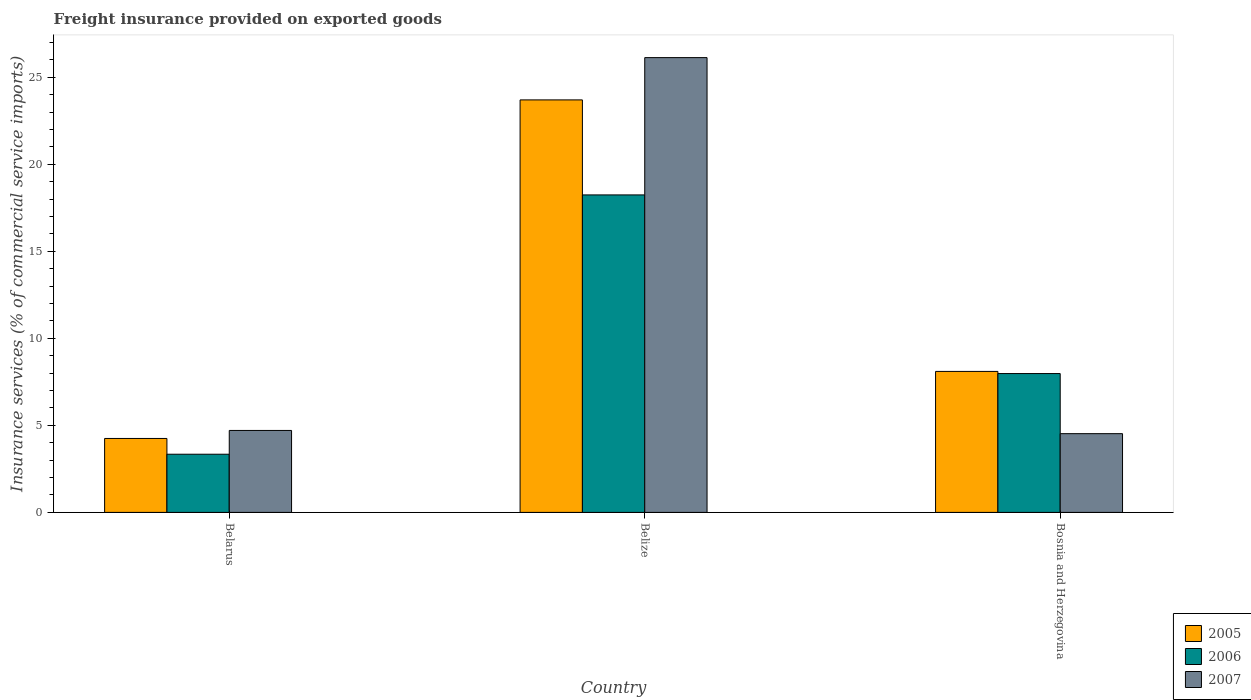How many groups of bars are there?
Offer a terse response. 3. Are the number of bars per tick equal to the number of legend labels?
Your response must be concise. Yes. How many bars are there on the 2nd tick from the right?
Your answer should be very brief. 3. What is the label of the 3rd group of bars from the left?
Offer a terse response. Bosnia and Herzegovina. What is the freight insurance provided on exported goods in 2007 in Belize?
Provide a succinct answer. 26.13. Across all countries, what is the maximum freight insurance provided on exported goods in 2007?
Ensure brevity in your answer.  26.13. Across all countries, what is the minimum freight insurance provided on exported goods in 2006?
Ensure brevity in your answer.  3.34. In which country was the freight insurance provided on exported goods in 2005 maximum?
Offer a terse response. Belize. In which country was the freight insurance provided on exported goods in 2007 minimum?
Offer a very short reply. Bosnia and Herzegovina. What is the total freight insurance provided on exported goods in 2006 in the graph?
Keep it short and to the point. 29.56. What is the difference between the freight insurance provided on exported goods in 2006 in Belarus and that in Bosnia and Herzegovina?
Your answer should be very brief. -4.63. What is the difference between the freight insurance provided on exported goods in 2007 in Belize and the freight insurance provided on exported goods in 2005 in Belarus?
Provide a succinct answer. 21.88. What is the average freight insurance provided on exported goods in 2006 per country?
Make the answer very short. 9.85. What is the difference between the freight insurance provided on exported goods of/in 2007 and freight insurance provided on exported goods of/in 2005 in Belize?
Your answer should be very brief. 2.43. In how many countries, is the freight insurance provided on exported goods in 2005 greater than 25 %?
Your response must be concise. 0. What is the ratio of the freight insurance provided on exported goods in 2007 in Belarus to that in Bosnia and Herzegovina?
Offer a terse response. 1.04. Is the freight insurance provided on exported goods in 2007 in Belarus less than that in Bosnia and Herzegovina?
Give a very brief answer. No. Is the difference between the freight insurance provided on exported goods in 2007 in Belarus and Belize greater than the difference between the freight insurance provided on exported goods in 2005 in Belarus and Belize?
Ensure brevity in your answer.  No. What is the difference between the highest and the second highest freight insurance provided on exported goods in 2007?
Ensure brevity in your answer.  21.42. What is the difference between the highest and the lowest freight insurance provided on exported goods in 2007?
Give a very brief answer. 21.6. In how many countries, is the freight insurance provided on exported goods in 2005 greater than the average freight insurance provided on exported goods in 2005 taken over all countries?
Provide a succinct answer. 1. Is the sum of the freight insurance provided on exported goods in 2005 in Belarus and Bosnia and Herzegovina greater than the maximum freight insurance provided on exported goods in 2006 across all countries?
Make the answer very short. No. Are all the bars in the graph horizontal?
Offer a terse response. No. How many countries are there in the graph?
Provide a short and direct response. 3. Does the graph contain any zero values?
Offer a terse response. No. Does the graph contain grids?
Give a very brief answer. No. Where does the legend appear in the graph?
Your answer should be compact. Bottom right. How many legend labels are there?
Provide a short and direct response. 3. How are the legend labels stacked?
Ensure brevity in your answer.  Vertical. What is the title of the graph?
Your response must be concise. Freight insurance provided on exported goods. What is the label or title of the X-axis?
Make the answer very short. Country. What is the label or title of the Y-axis?
Offer a very short reply. Insurance services (% of commercial service imports). What is the Insurance services (% of commercial service imports) of 2005 in Belarus?
Keep it short and to the point. 4.25. What is the Insurance services (% of commercial service imports) in 2006 in Belarus?
Your response must be concise. 3.34. What is the Insurance services (% of commercial service imports) in 2007 in Belarus?
Ensure brevity in your answer.  4.71. What is the Insurance services (% of commercial service imports) in 2005 in Belize?
Offer a terse response. 23.7. What is the Insurance services (% of commercial service imports) in 2006 in Belize?
Make the answer very short. 18.24. What is the Insurance services (% of commercial service imports) of 2007 in Belize?
Provide a succinct answer. 26.13. What is the Insurance services (% of commercial service imports) in 2005 in Bosnia and Herzegovina?
Make the answer very short. 8.1. What is the Insurance services (% of commercial service imports) of 2006 in Bosnia and Herzegovina?
Your answer should be compact. 7.98. What is the Insurance services (% of commercial service imports) of 2007 in Bosnia and Herzegovina?
Your response must be concise. 4.52. Across all countries, what is the maximum Insurance services (% of commercial service imports) of 2005?
Your response must be concise. 23.7. Across all countries, what is the maximum Insurance services (% of commercial service imports) of 2006?
Make the answer very short. 18.24. Across all countries, what is the maximum Insurance services (% of commercial service imports) in 2007?
Provide a short and direct response. 26.13. Across all countries, what is the minimum Insurance services (% of commercial service imports) of 2005?
Keep it short and to the point. 4.25. Across all countries, what is the minimum Insurance services (% of commercial service imports) of 2006?
Your response must be concise. 3.34. Across all countries, what is the minimum Insurance services (% of commercial service imports) of 2007?
Make the answer very short. 4.52. What is the total Insurance services (% of commercial service imports) in 2005 in the graph?
Your answer should be very brief. 36.04. What is the total Insurance services (% of commercial service imports) in 2006 in the graph?
Offer a terse response. 29.56. What is the total Insurance services (% of commercial service imports) of 2007 in the graph?
Make the answer very short. 35.36. What is the difference between the Insurance services (% of commercial service imports) of 2005 in Belarus and that in Belize?
Offer a very short reply. -19.45. What is the difference between the Insurance services (% of commercial service imports) of 2006 in Belarus and that in Belize?
Offer a terse response. -14.9. What is the difference between the Insurance services (% of commercial service imports) in 2007 in Belarus and that in Belize?
Ensure brevity in your answer.  -21.42. What is the difference between the Insurance services (% of commercial service imports) of 2005 in Belarus and that in Bosnia and Herzegovina?
Keep it short and to the point. -3.85. What is the difference between the Insurance services (% of commercial service imports) of 2006 in Belarus and that in Bosnia and Herzegovina?
Offer a terse response. -4.63. What is the difference between the Insurance services (% of commercial service imports) of 2007 in Belarus and that in Bosnia and Herzegovina?
Your answer should be compact. 0.18. What is the difference between the Insurance services (% of commercial service imports) of 2005 in Belize and that in Bosnia and Herzegovina?
Offer a terse response. 15.6. What is the difference between the Insurance services (% of commercial service imports) of 2006 in Belize and that in Bosnia and Herzegovina?
Your response must be concise. 10.26. What is the difference between the Insurance services (% of commercial service imports) of 2007 in Belize and that in Bosnia and Herzegovina?
Provide a succinct answer. 21.6. What is the difference between the Insurance services (% of commercial service imports) in 2005 in Belarus and the Insurance services (% of commercial service imports) in 2006 in Belize?
Keep it short and to the point. -13.99. What is the difference between the Insurance services (% of commercial service imports) in 2005 in Belarus and the Insurance services (% of commercial service imports) in 2007 in Belize?
Your answer should be very brief. -21.88. What is the difference between the Insurance services (% of commercial service imports) of 2006 in Belarus and the Insurance services (% of commercial service imports) of 2007 in Belize?
Your answer should be very brief. -22.78. What is the difference between the Insurance services (% of commercial service imports) of 2005 in Belarus and the Insurance services (% of commercial service imports) of 2006 in Bosnia and Herzegovina?
Your response must be concise. -3.73. What is the difference between the Insurance services (% of commercial service imports) of 2005 in Belarus and the Insurance services (% of commercial service imports) of 2007 in Bosnia and Herzegovina?
Offer a terse response. -0.28. What is the difference between the Insurance services (% of commercial service imports) in 2006 in Belarus and the Insurance services (% of commercial service imports) in 2007 in Bosnia and Herzegovina?
Your answer should be compact. -1.18. What is the difference between the Insurance services (% of commercial service imports) of 2005 in Belize and the Insurance services (% of commercial service imports) of 2006 in Bosnia and Herzegovina?
Make the answer very short. 15.72. What is the difference between the Insurance services (% of commercial service imports) of 2005 in Belize and the Insurance services (% of commercial service imports) of 2007 in Bosnia and Herzegovina?
Provide a short and direct response. 19.17. What is the difference between the Insurance services (% of commercial service imports) of 2006 in Belize and the Insurance services (% of commercial service imports) of 2007 in Bosnia and Herzegovina?
Keep it short and to the point. 13.71. What is the average Insurance services (% of commercial service imports) in 2005 per country?
Provide a short and direct response. 12.01. What is the average Insurance services (% of commercial service imports) of 2006 per country?
Ensure brevity in your answer.  9.85. What is the average Insurance services (% of commercial service imports) of 2007 per country?
Your answer should be very brief. 11.79. What is the difference between the Insurance services (% of commercial service imports) of 2005 and Insurance services (% of commercial service imports) of 2006 in Belarus?
Offer a terse response. 0.91. What is the difference between the Insurance services (% of commercial service imports) of 2005 and Insurance services (% of commercial service imports) of 2007 in Belarus?
Ensure brevity in your answer.  -0.46. What is the difference between the Insurance services (% of commercial service imports) in 2006 and Insurance services (% of commercial service imports) in 2007 in Belarus?
Provide a short and direct response. -1.37. What is the difference between the Insurance services (% of commercial service imports) of 2005 and Insurance services (% of commercial service imports) of 2006 in Belize?
Your answer should be compact. 5.46. What is the difference between the Insurance services (% of commercial service imports) of 2005 and Insurance services (% of commercial service imports) of 2007 in Belize?
Make the answer very short. -2.43. What is the difference between the Insurance services (% of commercial service imports) of 2006 and Insurance services (% of commercial service imports) of 2007 in Belize?
Offer a very short reply. -7.89. What is the difference between the Insurance services (% of commercial service imports) of 2005 and Insurance services (% of commercial service imports) of 2006 in Bosnia and Herzegovina?
Provide a succinct answer. 0.12. What is the difference between the Insurance services (% of commercial service imports) of 2005 and Insurance services (% of commercial service imports) of 2007 in Bosnia and Herzegovina?
Offer a terse response. 3.58. What is the difference between the Insurance services (% of commercial service imports) of 2006 and Insurance services (% of commercial service imports) of 2007 in Bosnia and Herzegovina?
Ensure brevity in your answer.  3.45. What is the ratio of the Insurance services (% of commercial service imports) in 2005 in Belarus to that in Belize?
Offer a terse response. 0.18. What is the ratio of the Insurance services (% of commercial service imports) of 2006 in Belarus to that in Belize?
Offer a very short reply. 0.18. What is the ratio of the Insurance services (% of commercial service imports) of 2007 in Belarus to that in Belize?
Offer a terse response. 0.18. What is the ratio of the Insurance services (% of commercial service imports) of 2005 in Belarus to that in Bosnia and Herzegovina?
Provide a succinct answer. 0.52. What is the ratio of the Insurance services (% of commercial service imports) of 2006 in Belarus to that in Bosnia and Herzegovina?
Give a very brief answer. 0.42. What is the ratio of the Insurance services (% of commercial service imports) of 2007 in Belarus to that in Bosnia and Herzegovina?
Provide a short and direct response. 1.04. What is the ratio of the Insurance services (% of commercial service imports) of 2005 in Belize to that in Bosnia and Herzegovina?
Keep it short and to the point. 2.93. What is the ratio of the Insurance services (% of commercial service imports) of 2006 in Belize to that in Bosnia and Herzegovina?
Your answer should be very brief. 2.29. What is the ratio of the Insurance services (% of commercial service imports) of 2007 in Belize to that in Bosnia and Herzegovina?
Provide a succinct answer. 5.78. What is the difference between the highest and the second highest Insurance services (% of commercial service imports) of 2005?
Provide a succinct answer. 15.6. What is the difference between the highest and the second highest Insurance services (% of commercial service imports) of 2006?
Offer a terse response. 10.26. What is the difference between the highest and the second highest Insurance services (% of commercial service imports) in 2007?
Offer a very short reply. 21.42. What is the difference between the highest and the lowest Insurance services (% of commercial service imports) of 2005?
Provide a short and direct response. 19.45. What is the difference between the highest and the lowest Insurance services (% of commercial service imports) in 2006?
Your answer should be compact. 14.9. What is the difference between the highest and the lowest Insurance services (% of commercial service imports) in 2007?
Give a very brief answer. 21.6. 